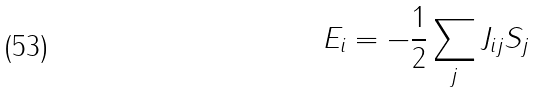Convert formula to latex. <formula><loc_0><loc_0><loc_500><loc_500>E _ { i } = - \frac { 1 } { 2 } \sum _ { j } J _ { i j } S _ { j }</formula> 